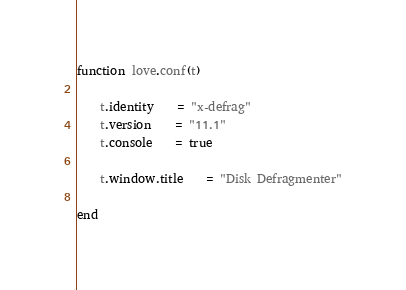Convert code to text. <code><loc_0><loc_0><loc_500><loc_500><_Lua_>function love.conf(t)

	t.identity	= "x-defrag"
	t.version	= "11.1"
	t.console	= true

	t.window.title	= "Disk Defragmenter"

end
</code> 